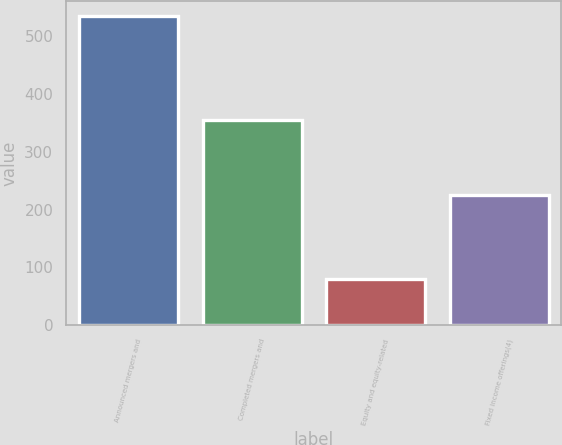Convert chart. <chart><loc_0><loc_0><loc_500><loc_500><bar_chart><fcel>Announced mergers and<fcel>Completed mergers and<fcel>Equity and equity-related<fcel>Fixed income offerings(4)<nl><fcel>535<fcel>356<fcel>80<fcel>225<nl></chart> 